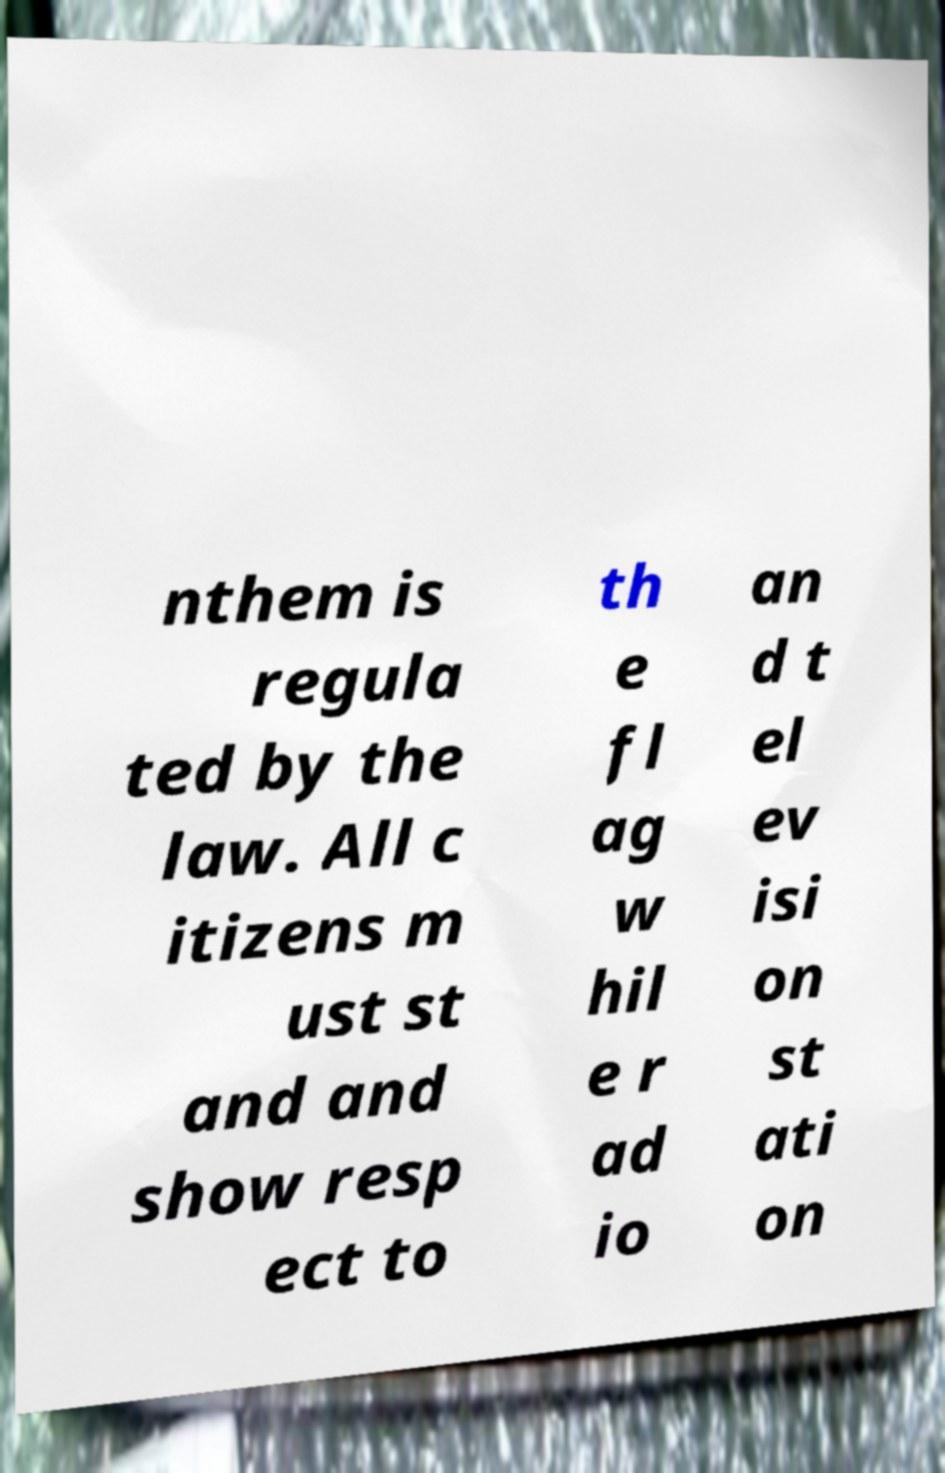For documentation purposes, I need the text within this image transcribed. Could you provide that? nthem is regula ted by the law. All c itizens m ust st and and show resp ect to th e fl ag w hil e r ad io an d t el ev isi on st ati on 